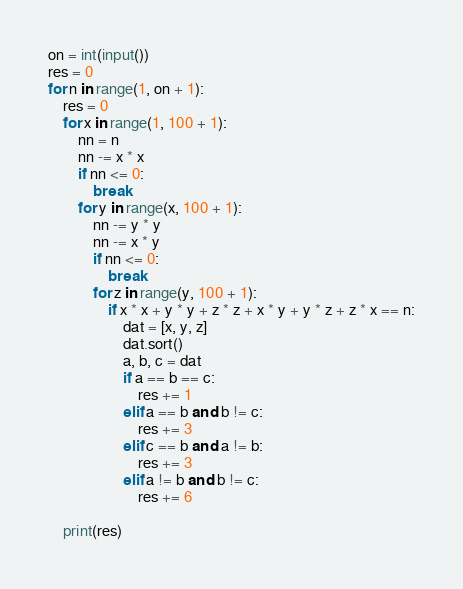<code> <loc_0><loc_0><loc_500><loc_500><_Python_>on = int(input())
res = 0
for n in range(1, on + 1):
    res = 0
    for x in range(1, 100 + 1):
        nn = n
        nn -= x * x
        if nn <= 0:
            break
        for y in range(x, 100 + 1):
            nn -= y * y
            nn -= x * y
            if nn <= 0:
                break
            for z in range(y, 100 + 1):
                if x * x + y * y + z * z + x * y + y * z + z * x == n:
                    dat = [x, y, z]
                    dat.sort()
                    a, b, c = dat
                    if a == b == c:
                        res += 1
                    elif a == b and b != c:
                        res += 3
                    elif c == b and a != b:
                        res += 3
                    elif a != b and b != c:
                        res += 6

    print(res)
</code> 